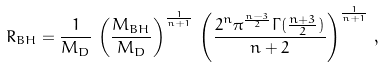<formula> <loc_0><loc_0><loc_500><loc_500>R _ { B H } = \frac { 1 } { M _ { D } } \, \left ( \frac { M _ { B H } } { M _ { D } } \right ) ^ { \frac { 1 } { n + 1 } } \, \left ( \frac { 2 ^ { n } \pi ^ { \frac { n - 3 } { 2 } } \Gamma ( \frac { n + 3 } { 2 } ) } { n + 2 } \right ) ^ { \frac { 1 } { n + 1 } } \, ,</formula> 